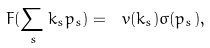<formula> <loc_0><loc_0><loc_500><loc_500>F ( \sum _ { s } k _ { s } p _ { s } ) = \ v ( k _ { s } ) \sigma ( p _ { s } ) ,</formula> 